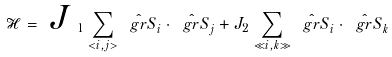<formula> <loc_0><loc_0><loc_500><loc_500>\mathcal { H } = \emph { J } _ { 1 } \sum _ { < i , j > } \hat { \ g r { S } } _ { i } \cdot \hat { \ g r { S } } _ { j } + { J } _ { 2 } \sum _ { \ll i , k \gg } \hat { \ g r { S } } _ { i } \cdot \hat { \ g r { S } } _ { k }</formula> 